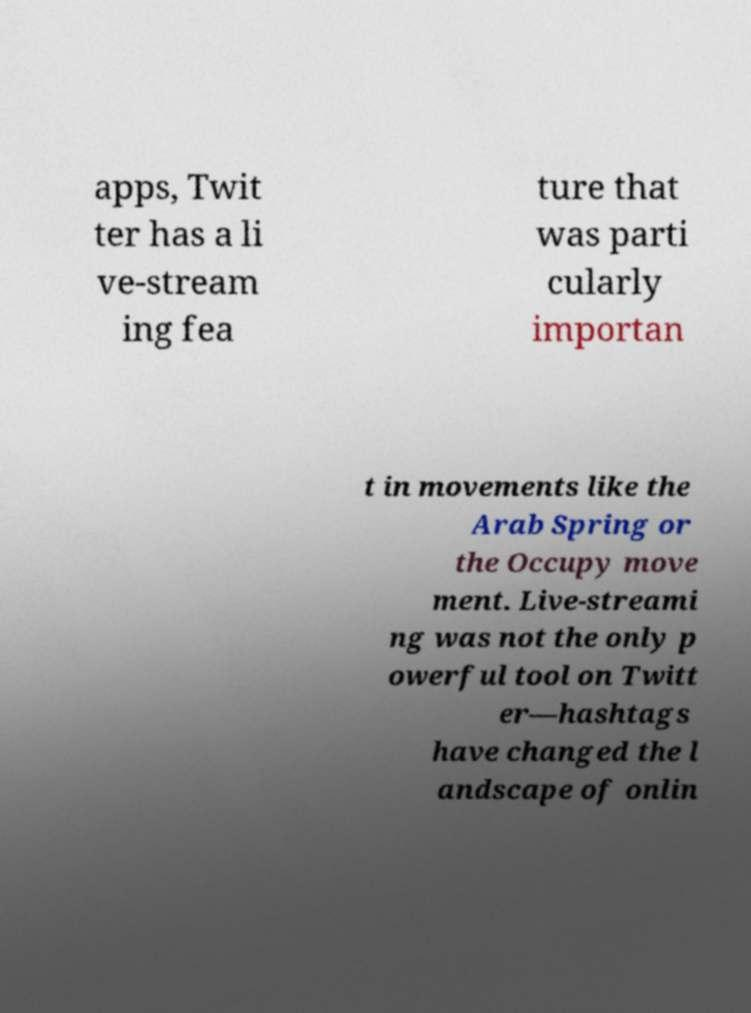I need the written content from this picture converted into text. Can you do that? apps, Twit ter has a li ve-stream ing fea ture that was parti cularly importan t in movements like the Arab Spring or the Occupy move ment. Live-streami ng was not the only p owerful tool on Twitt er—hashtags have changed the l andscape of onlin 